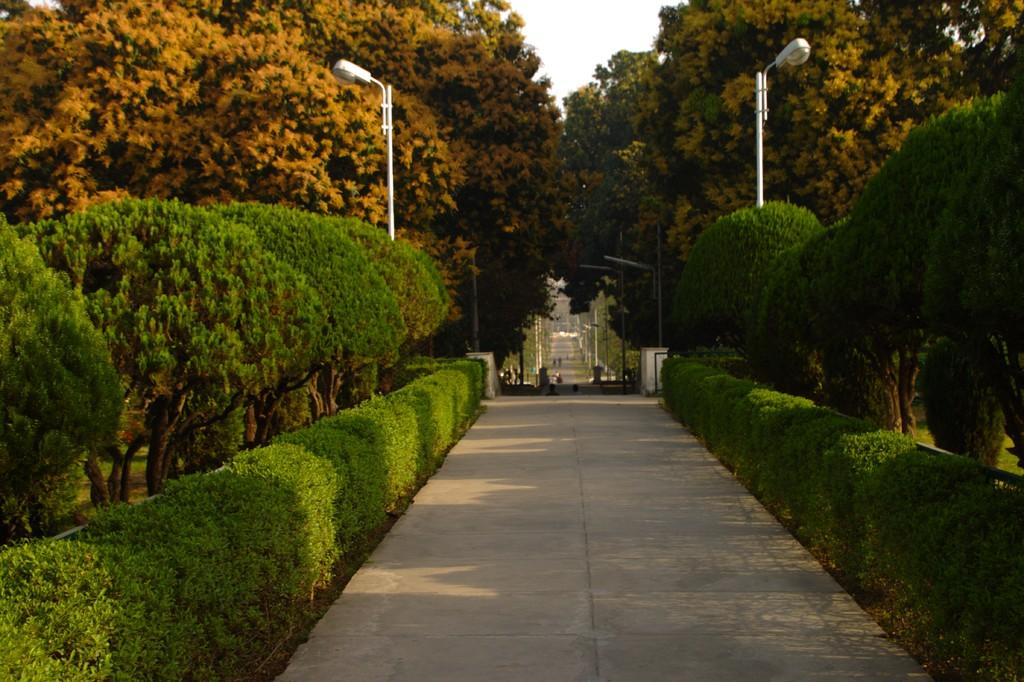What type of vegetation can be seen in the image? There are plants and trees in the image. What structures are present in the image? There are light poles in the image. What type of pathway is visible in the image? There is a road visible in the image. What part of the natural environment is visible in the image? The sky is visible in the image. What type of toy can be seen on the tray in the image? There is no tray or toy present in the image. 